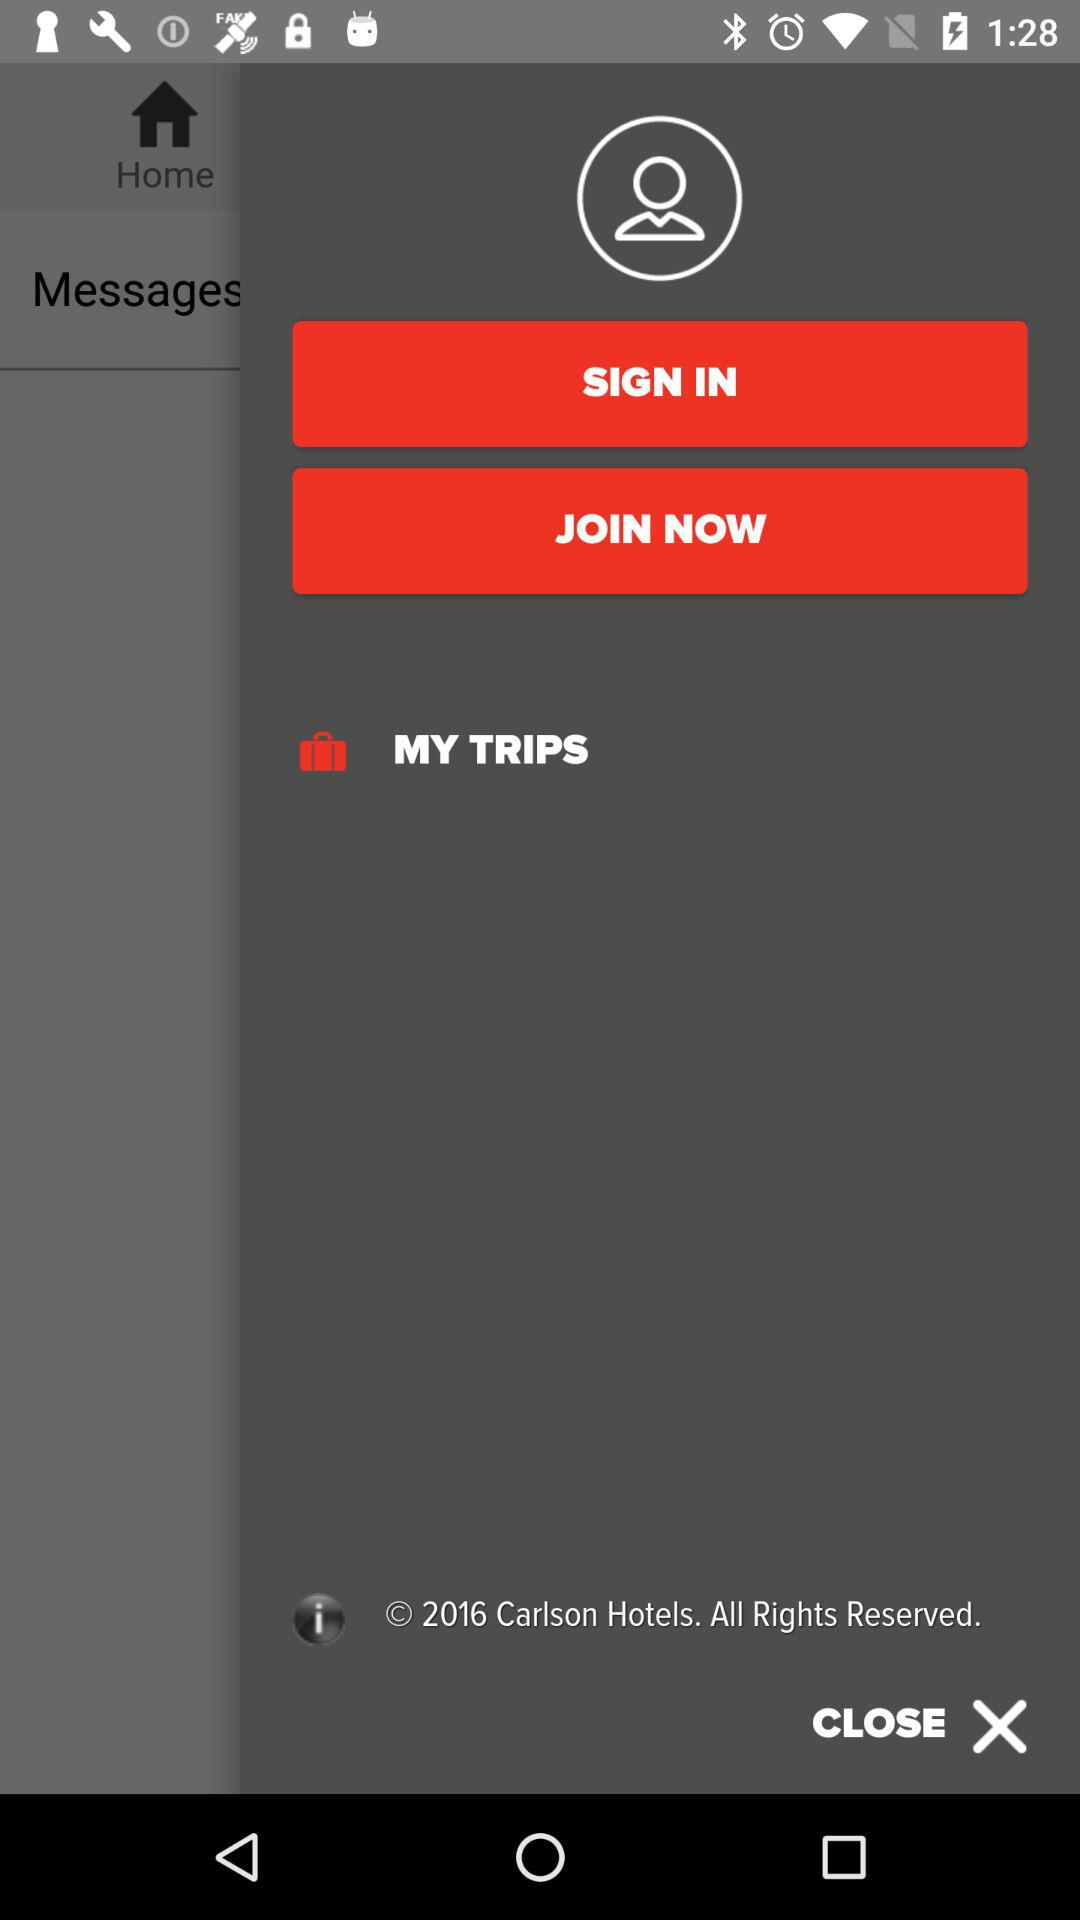What is the year of copyright of the application? The year is 2016. 